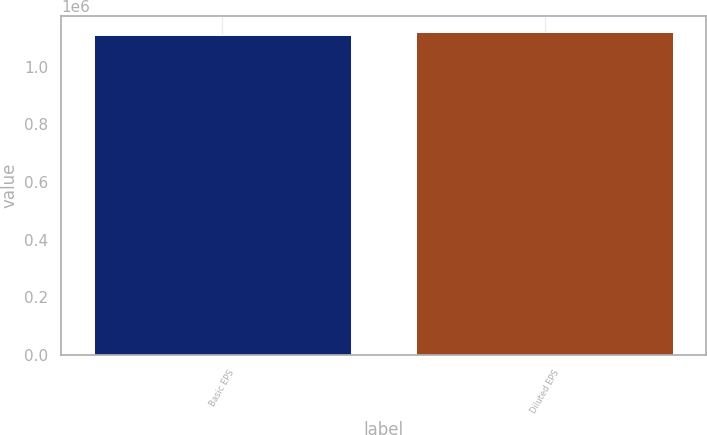Convert chart. <chart><loc_0><loc_0><loc_500><loc_500><bar_chart><fcel>Basic EPS<fcel>Diluted EPS<nl><fcel>1.10921e+06<fcel>1.11855e+06<nl></chart> 